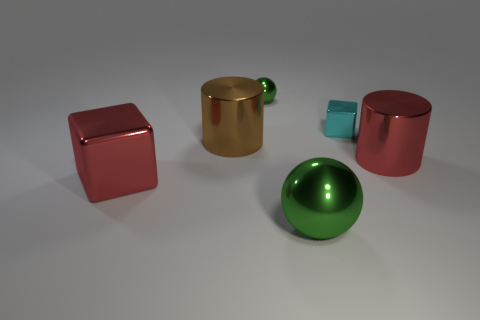Subtract all green balls. How many were subtracted if there are1green balls left? 1 Add 2 cyan things. How many objects exist? 8 Subtract all spheres. How many objects are left? 4 Add 5 big blocks. How many big blocks are left? 6 Add 6 small blue rubber cubes. How many small blue rubber cubes exist? 6 Subtract 0 purple blocks. How many objects are left? 6 Subtract all big red rubber objects. Subtract all green shiny objects. How many objects are left? 4 